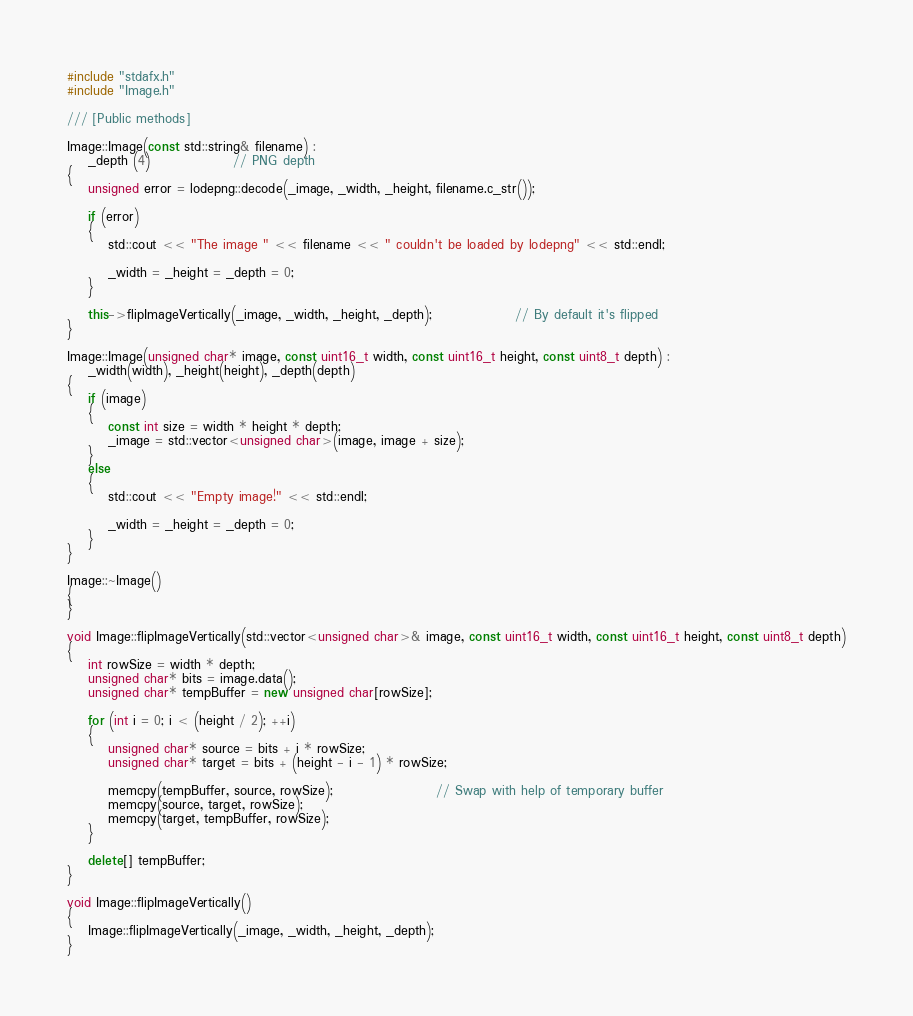Convert code to text. <code><loc_0><loc_0><loc_500><loc_500><_C++_>#include "stdafx.h"
#include "Image.h"

/// [Public methods]

Image::Image(const std::string& filename) :
	_depth (4)				// PNG depth
{
	unsigned error = lodepng::decode(_image, _width, _height, filename.c_str());

	if (error)
	{
		std::cout << "The image " << filename << " couldn't be loaded by lodepng" << std::endl;

		_width = _height = _depth = 0;
	}

	this->flipImageVertically(_image, _width, _height, _depth);				// By default it's flipped
}

Image::Image(unsigned char* image, const uint16_t width, const uint16_t height, const uint8_t depth) :
	_width(width), _height(height), _depth(depth)
{
	if (image)
	{
		const int size = width * height * depth;
		_image = std::vector<unsigned char>(image, image + size);
	}
	else
	{
		std::cout << "Empty image!" << std::endl;

		_width = _height = _depth = 0;
	}
}

Image::~Image()
{
}

void Image::flipImageVertically(std::vector<unsigned char>& image, const uint16_t width, const uint16_t height, const uint8_t depth)
{
	int rowSize = width * depth;
	unsigned char* bits = image.data();
	unsigned char* tempBuffer = new unsigned char[rowSize];

	for (int i = 0; i < (height / 2); ++i)
	{
		unsigned char* source = bits + i * rowSize;
		unsigned char* target = bits + (height - i - 1) * rowSize;

		memcpy(tempBuffer, source, rowSize);					// Swap with help of temporary buffer
		memcpy(source, target, rowSize);
		memcpy(target, tempBuffer, rowSize);
	}

	delete[] tempBuffer;
}

void Image::flipImageVertically()
{
	Image::flipImageVertically(_image, _width, _height, _depth);
}</code> 